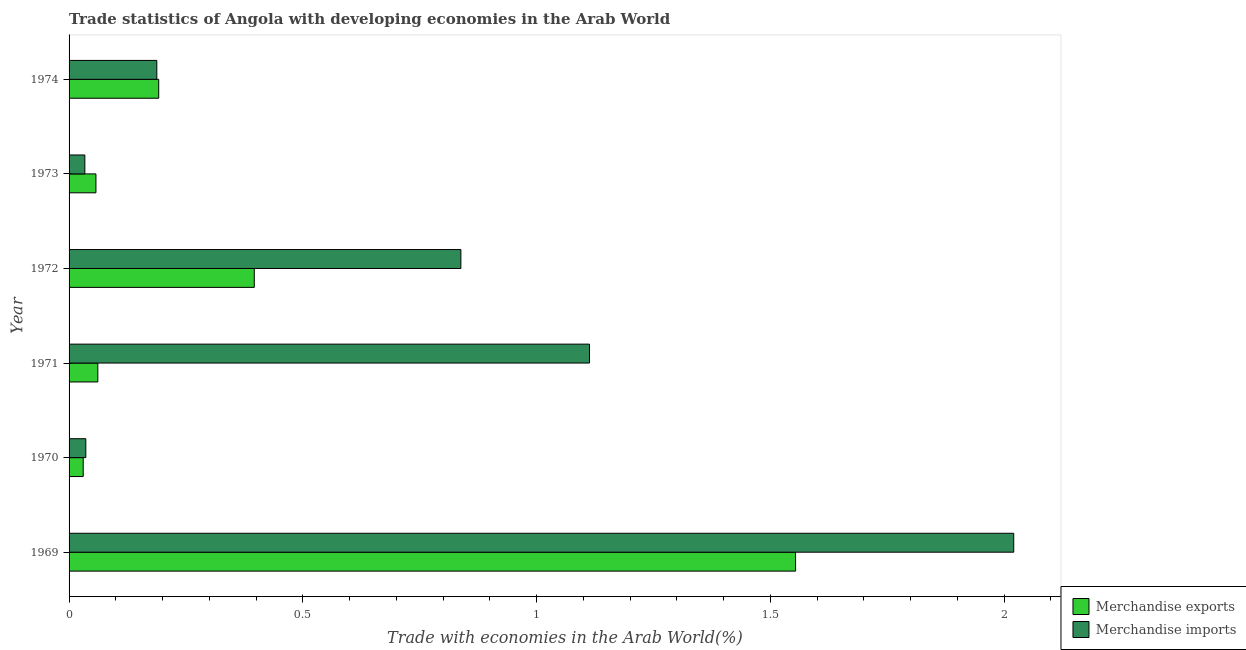How many different coloured bars are there?
Your response must be concise. 2. How many bars are there on the 1st tick from the top?
Provide a succinct answer. 2. How many bars are there on the 3rd tick from the bottom?
Offer a terse response. 2. What is the label of the 6th group of bars from the top?
Your answer should be compact. 1969. What is the merchandise imports in 1974?
Offer a terse response. 0.19. Across all years, what is the maximum merchandise imports?
Ensure brevity in your answer.  2.02. Across all years, what is the minimum merchandise imports?
Make the answer very short. 0.03. In which year was the merchandise exports maximum?
Provide a short and direct response. 1969. What is the total merchandise imports in the graph?
Your response must be concise. 4.23. What is the difference between the merchandise imports in 1972 and that in 1973?
Offer a terse response. 0.8. What is the difference between the merchandise exports in 1972 and the merchandise imports in 1970?
Provide a short and direct response. 0.36. What is the average merchandise imports per year?
Your answer should be very brief. 0.7. In the year 1969, what is the difference between the merchandise imports and merchandise exports?
Offer a terse response. 0.47. In how many years, is the merchandise imports greater than 0.4 %?
Offer a very short reply. 3. What is the ratio of the merchandise exports in 1970 to that in 1972?
Keep it short and to the point. 0.08. Is the merchandise imports in 1970 less than that in 1971?
Your answer should be compact. Yes. Is the difference between the merchandise exports in 1969 and 1971 greater than the difference between the merchandise imports in 1969 and 1971?
Ensure brevity in your answer.  Yes. What is the difference between the highest and the second highest merchandise exports?
Your response must be concise. 1.16. What is the difference between the highest and the lowest merchandise exports?
Your response must be concise. 1.52. In how many years, is the merchandise exports greater than the average merchandise exports taken over all years?
Your answer should be compact. 2. Is the sum of the merchandise imports in 1969 and 1974 greater than the maximum merchandise exports across all years?
Your answer should be very brief. Yes. What does the 2nd bar from the bottom in 1971 represents?
Make the answer very short. Merchandise imports. How many bars are there?
Offer a very short reply. 12. How many years are there in the graph?
Keep it short and to the point. 6. What is the difference between two consecutive major ticks on the X-axis?
Ensure brevity in your answer.  0.5. Are the values on the major ticks of X-axis written in scientific E-notation?
Your answer should be compact. No. Does the graph contain any zero values?
Offer a very short reply. No. Where does the legend appear in the graph?
Provide a succinct answer. Bottom right. How are the legend labels stacked?
Offer a very short reply. Vertical. What is the title of the graph?
Your response must be concise. Trade statistics of Angola with developing economies in the Arab World. What is the label or title of the X-axis?
Your response must be concise. Trade with economies in the Arab World(%). What is the label or title of the Y-axis?
Your answer should be compact. Year. What is the Trade with economies in the Arab World(%) in Merchandise exports in 1969?
Provide a succinct answer. 1.55. What is the Trade with economies in the Arab World(%) in Merchandise imports in 1969?
Your answer should be very brief. 2.02. What is the Trade with economies in the Arab World(%) in Merchandise exports in 1970?
Offer a terse response. 0.03. What is the Trade with economies in the Arab World(%) in Merchandise imports in 1970?
Your answer should be very brief. 0.04. What is the Trade with economies in the Arab World(%) in Merchandise exports in 1971?
Give a very brief answer. 0.06. What is the Trade with economies in the Arab World(%) of Merchandise imports in 1971?
Provide a short and direct response. 1.11. What is the Trade with economies in the Arab World(%) of Merchandise exports in 1972?
Your answer should be very brief. 0.4. What is the Trade with economies in the Arab World(%) of Merchandise imports in 1972?
Provide a succinct answer. 0.84. What is the Trade with economies in the Arab World(%) of Merchandise exports in 1973?
Keep it short and to the point. 0.06. What is the Trade with economies in the Arab World(%) of Merchandise imports in 1973?
Ensure brevity in your answer.  0.03. What is the Trade with economies in the Arab World(%) in Merchandise exports in 1974?
Make the answer very short. 0.19. What is the Trade with economies in the Arab World(%) in Merchandise imports in 1974?
Provide a succinct answer. 0.19. Across all years, what is the maximum Trade with economies in the Arab World(%) in Merchandise exports?
Your answer should be very brief. 1.55. Across all years, what is the maximum Trade with economies in the Arab World(%) of Merchandise imports?
Ensure brevity in your answer.  2.02. Across all years, what is the minimum Trade with economies in the Arab World(%) in Merchandise exports?
Keep it short and to the point. 0.03. Across all years, what is the minimum Trade with economies in the Arab World(%) of Merchandise imports?
Offer a terse response. 0.03. What is the total Trade with economies in the Arab World(%) of Merchandise exports in the graph?
Your answer should be compact. 2.29. What is the total Trade with economies in the Arab World(%) in Merchandise imports in the graph?
Your response must be concise. 4.23. What is the difference between the Trade with economies in the Arab World(%) in Merchandise exports in 1969 and that in 1970?
Ensure brevity in your answer.  1.52. What is the difference between the Trade with economies in the Arab World(%) of Merchandise imports in 1969 and that in 1970?
Your response must be concise. 1.98. What is the difference between the Trade with economies in the Arab World(%) in Merchandise exports in 1969 and that in 1971?
Offer a very short reply. 1.49. What is the difference between the Trade with economies in the Arab World(%) of Merchandise imports in 1969 and that in 1971?
Provide a short and direct response. 0.91. What is the difference between the Trade with economies in the Arab World(%) in Merchandise exports in 1969 and that in 1972?
Keep it short and to the point. 1.16. What is the difference between the Trade with economies in the Arab World(%) of Merchandise imports in 1969 and that in 1972?
Provide a succinct answer. 1.18. What is the difference between the Trade with economies in the Arab World(%) of Merchandise exports in 1969 and that in 1973?
Give a very brief answer. 1.5. What is the difference between the Trade with economies in the Arab World(%) in Merchandise imports in 1969 and that in 1973?
Your answer should be very brief. 1.99. What is the difference between the Trade with economies in the Arab World(%) in Merchandise exports in 1969 and that in 1974?
Your answer should be compact. 1.36. What is the difference between the Trade with economies in the Arab World(%) in Merchandise imports in 1969 and that in 1974?
Keep it short and to the point. 1.83. What is the difference between the Trade with economies in the Arab World(%) of Merchandise exports in 1970 and that in 1971?
Ensure brevity in your answer.  -0.03. What is the difference between the Trade with economies in the Arab World(%) in Merchandise imports in 1970 and that in 1971?
Keep it short and to the point. -1.08. What is the difference between the Trade with economies in the Arab World(%) in Merchandise exports in 1970 and that in 1972?
Offer a very short reply. -0.37. What is the difference between the Trade with economies in the Arab World(%) in Merchandise imports in 1970 and that in 1972?
Make the answer very short. -0.8. What is the difference between the Trade with economies in the Arab World(%) in Merchandise exports in 1970 and that in 1973?
Your answer should be very brief. -0.03. What is the difference between the Trade with economies in the Arab World(%) in Merchandise imports in 1970 and that in 1973?
Your answer should be compact. 0. What is the difference between the Trade with economies in the Arab World(%) of Merchandise exports in 1970 and that in 1974?
Give a very brief answer. -0.16. What is the difference between the Trade with economies in the Arab World(%) of Merchandise imports in 1970 and that in 1974?
Give a very brief answer. -0.15. What is the difference between the Trade with economies in the Arab World(%) of Merchandise exports in 1971 and that in 1972?
Your response must be concise. -0.33. What is the difference between the Trade with economies in the Arab World(%) of Merchandise imports in 1971 and that in 1972?
Offer a very short reply. 0.28. What is the difference between the Trade with economies in the Arab World(%) of Merchandise exports in 1971 and that in 1973?
Your response must be concise. 0. What is the difference between the Trade with economies in the Arab World(%) of Merchandise imports in 1971 and that in 1973?
Give a very brief answer. 1.08. What is the difference between the Trade with economies in the Arab World(%) in Merchandise exports in 1971 and that in 1974?
Give a very brief answer. -0.13. What is the difference between the Trade with economies in the Arab World(%) in Merchandise imports in 1971 and that in 1974?
Your answer should be very brief. 0.93. What is the difference between the Trade with economies in the Arab World(%) of Merchandise exports in 1972 and that in 1973?
Provide a short and direct response. 0.34. What is the difference between the Trade with economies in the Arab World(%) of Merchandise imports in 1972 and that in 1973?
Your answer should be compact. 0.8. What is the difference between the Trade with economies in the Arab World(%) in Merchandise exports in 1972 and that in 1974?
Your answer should be very brief. 0.2. What is the difference between the Trade with economies in the Arab World(%) of Merchandise imports in 1972 and that in 1974?
Make the answer very short. 0.65. What is the difference between the Trade with economies in the Arab World(%) of Merchandise exports in 1973 and that in 1974?
Offer a very short reply. -0.13. What is the difference between the Trade with economies in the Arab World(%) in Merchandise imports in 1973 and that in 1974?
Give a very brief answer. -0.15. What is the difference between the Trade with economies in the Arab World(%) in Merchandise exports in 1969 and the Trade with economies in the Arab World(%) in Merchandise imports in 1970?
Your answer should be very brief. 1.52. What is the difference between the Trade with economies in the Arab World(%) in Merchandise exports in 1969 and the Trade with economies in the Arab World(%) in Merchandise imports in 1971?
Ensure brevity in your answer.  0.44. What is the difference between the Trade with economies in the Arab World(%) of Merchandise exports in 1969 and the Trade with economies in the Arab World(%) of Merchandise imports in 1972?
Offer a very short reply. 0.72. What is the difference between the Trade with economies in the Arab World(%) in Merchandise exports in 1969 and the Trade with economies in the Arab World(%) in Merchandise imports in 1973?
Offer a very short reply. 1.52. What is the difference between the Trade with economies in the Arab World(%) in Merchandise exports in 1969 and the Trade with economies in the Arab World(%) in Merchandise imports in 1974?
Give a very brief answer. 1.37. What is the difference between the Trade with economies in the Arab World(%) in Merchandise exports in 1970 and the Trade with economies in the Arab World(%) in Merchandise imports in 1971?
Give a very brief answer. -1.08. What is the difference between the Trade with economies in the Arab World(%) of Merchandise exports in 1970 and the Trade with economies in the Arab World(%) of Merchandise imports in 1972?
Your answer should be compact. -0.81. What is the difference between the Trade with economies in the Arab World(%) in Merchandise exports in 1970 and the Trade with economies in the Arab World(%) in Merchandise imports in 1973?
Offer a terse response. -0. What is the difference between the Trade with economies in the Arab World(%) in Merchandise exports in 1970 and the Trade with economies in the Arab World(%) in Merchandise imports in 1974?
Your answer should be compact. -0.16. What is the difference between the Trade with economies in the Arab World(%) of Merchandise exports in 1971 and the Trade with economies in the Arab World(%) of Merchandise imports in 1972?
Keep it short and to the point. -0.78. What is the difference between the Trade with economies in the Arab World(%) in Merchandise exports in 1971 and the Trade with economies in the Arab World(%) in Merchandise imports in 1973?
Offer a very short reply. 0.03. What is the difference between the Trade with economies in the Arab World(%) of Merchandise exports in 1971 and the Trade with economies in the Arab World(%) of Merchandise imports in 1974?
Offer a terse response. -0.13. What is the difference between the Trade with economies in the Arab World(%) of Merchandise exports in 1972 and the Trade with economies in the Arab World(%) of Merchandise imports in 1973?
Your answer should be compact. 0.36. What is the difference between the Trade with economies in the Arab World(%) of Merchandise exports in 1972 and the Trade with economies in the Arab World(%) of Merchandise imports in 1974?
Provide a short and direct response. 0.21. What is the difference between the Trade with economies in the Arab World(%) in Merchandise exports in 1973 and the Trade with economies in the Arab World(%) in Merchandise imports in 1974?
Give a very brief answer. -0.13. What is the average Trade with economies in the Arab World(%) in Merchandise exports per year?
Make the answer very short. 0.38. What is the average Trade with economies in the Arab World(%) in Merchandise imports per year?
Give a very brief answer. 0.7. In the year 1969, what is the difference between the Trade with economies in the Arab World(%) of Merchandise exports and Trade with economies in the Arab World(%) of Merchandise imports?
Ensure brevity in your answer.  -0.47. In the year 1970, what is the difference between the Trade with economies in the Arab World(%) of Merchandise exports and Trade with economies in the Arab World(%) of Merchandise imports?
Your response must be concise. -0.01. In the year 1971, what is the difference between the Trade with economies in the Arab World(%) of Merchandise exports and Trade with economies in the Arab World(%) of Merchandise imports?
Your response must be concise. -1.05. In the year 1972, what is the difference between the Trade with economies in the Arab World(%) in Merchandise exports and Trade with economies in the Arab World(%) in Merchandise imports?
Offer a very short reply. -0.44. In the year 1973, what is the difference between the Trade with economies in the Arab World(%) of Merchandise exports and Trade with economies in the Arab World(%) of Merchandise imports?
Make the answer very short. 0.02. In the year 1974, what is the difference between the Trade with economies in the Arab World(%) in Merchandise exports and Trade with economies in the Arab World(%) in Merchandise imports?
Your response must be concise. 0. What is the ratio of the Trade with economies in the Arab World(%) of Merchandise exports in 1969 to that in 1970?
Your answer should be very brief. 51.4. What is the ratio of the Trade with economies in the Arab World(%) of Merchandise imports in 1969 to that in 1970?
Your response must be concise. 56.42. What is the ratio of the Trade with economies in the Arab World(%) of Merchandise exports in 1969 to that in 1971?
Make the answer very short. 25.26. What is the ratio of the Trade with economies in the Arab World(%) of Merchandise imports in 1969 to that in 1971?
Make the answer very short. 1.82. What is the ratio of the Trade with economies in the Arab World(%) in Merchandise exports in 1969 to that in 1972?
Provide a succinct answer. 3.92. What is the ratio of the Trade with economies in the Arab World(%) of Merchandise imports in 1969 to that in 1972?
Your answer should be compact. 2.41. What is the ratio of the Trade with economies in the Arab World(%) in Merchandise exports in 1969 to that in 1973?
Offer a terse response. 27.03. What is the ratio of the Trade with economies in the Arab World(%) of Merchandise imports in 1969 to that in 1973?
Your answer should be very brief. 59.92. What is the ratio of the Trade with economies in the Arab World(%) of Merchandise exports in 1969 to that in 1974?
Offer a very short reply. 8.1. What is the ratio of the Trade with economies in the Arab World(%) in Merchandise imports in 1969 to that in 1974?
Your answer should be compact. 10.77. What is the ratio of the Trade with economies in the Arab World(%) of Merchandise exports in 1970 to that in 1971?
Your answer should be very brief. 0.49. What is the ratio of the Trade with economies in the Arab World(%) of Merchandise imports in 1970 to that in 1971?
Offer a very short reply. 0.03. What is the ratio of the Trade with economies in the Arab World(%) in Merchandise exports in 1970 to that in 1972?
Ensure brevity in your answer.  0.08. What is the ratio of the Trade with economies in the Arab World(%) in Merchandise imports in 1970 to that in 1972?
Keep it short and to the point. 0.04. What is the ratio of the Trade with economies in the Arab World(%) of Merchandise exports in 1970 to that in 1973?
Make the answer very short. 0.53. What is the ratio of the Trade with economies in the Arab World(%) of Merchandise imports in 1970 to that in 1973?
Keep it short and to the point. 1.06. What is the ratio of the Trade with economies in the Arab World(%) of Merchandise exports in 1970 to that in 1974?
Your answer should be very brief. 0.16. What is the ratio of the Trade with economies in the Arab World(%) of Merchandise imports in 1970 to that in 1974?
Your response must be concise. 0.19. What is the ratio of the Trade with economies in the Arab World(%) of Merchandise exports in 1971 to that in 1972?
Offer a terse response. 0.16. What is the ratio of the Trade with economies in the Arab World(%) in Merchandise imports in 1971 to that in 1972?
Ensure brevity in your answer.  1.33. What is the ratio of the Trade with economies in the Arab World(%) of Merchandise exports in 1971 to that in 1973?
Your answer should be very brief. 1.07. What is the ratio of the Trade with economies in the Arab World(%) in Merchandise imports in 1971 to that in 1973?
Your answer should be compact. 33.01. What is the ratio of the Trade with economies in the Arab World(%) of Merchandise exports in 1971 to that in 1974?
Offer a terse response. 0.32. What is the ratio of the Trade with economies in the Arab World(%) of Merchandise imports in 1971 to that in 1974?
Give a very brief answer. 5.93. What is the ratio of the Trade with economies in the Arab World(%) of Merchandise exports in 1972 to that in 1973?
Give a very brief answer. 6.89. What is the ratio of the Trade with economies in the Arab World(%) in Merchandise imports in 1972 to that in 1973?
Offer a very short reply. 24.85. What is the ratio of the Trade with economies in the Arab World(%) of Merchandise exports in 1972 to that in 1974?
Your response must be concise. 2.07. What is the ratio of the Trade with economies in the Arab World(%) of Merchandise imports in 1972 to that in 1974?
Your response must be concise. 4.47. What is the ratio of the Trade with economies in the Arab World(%) of Merchandise exports in 1973 to that in 1974?
Provide a succinct answer. 0.3. What is the ratio of the Trade with economies in the Arab World(%) in Merchandise imports in 1973 to that in 1974?
Offer a terse response. 0.18. What is the difference between the highest and the second highest Trade with economies in the Arab World(%) in Merchandise exports?
Provide a short and direct response. 1.16. What is the difference between the highest and the second highest Trade with economies in the Arab World(%) in Merchandise imports?
Ensure brevity in your answer.  0.91. What is the difference between the highest and the lowest Trade with economies in the Arab World(%) of Merchandise exports?
Your response must be concise. 1.52. What is the difference between the highest and the lowest Trade with economies in the Arab World(%) of Merchandise imports?
Keep it short and to the point. 1.99. 